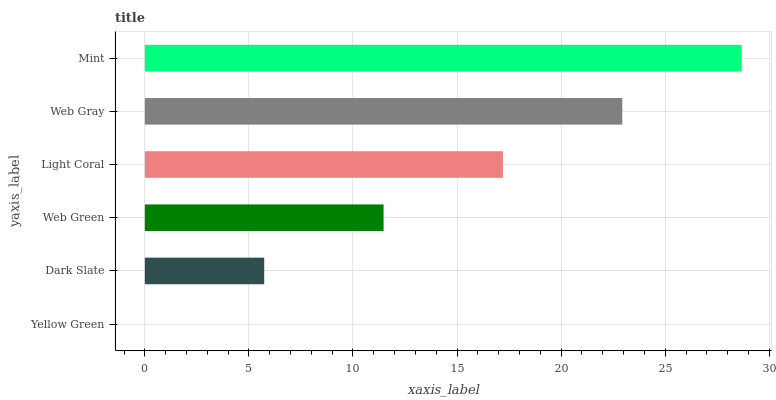Is Yellow Green the minimum?
Answer yes or no. Yes. Is Mint the maximum?
Answer yes or no. Yes. Is Dark Slate the minimum?
Answer yes or no. No. Is Dark Slate the maximum?
Answer yes or no. No. Is Dark Slate greater than Yellow Green?
Answer yes or no. Yes. Is Yellow Green less than Dark Slate?
Answer yes or no. Yes. Is Yellow Green greater than Dark Slate?
Answer yes or no. No. Is Dark Slate less than Yellow Green?
Answer yes or no. No. Is Light Coral the high median?
Answer yes or no. Yes. Is Web Green the low median?
Answer yes or no. Yes. Is Web Gray the high median?
Answer yes or no. No. Is Light Coral the low median?
Answer yes or no. No. 